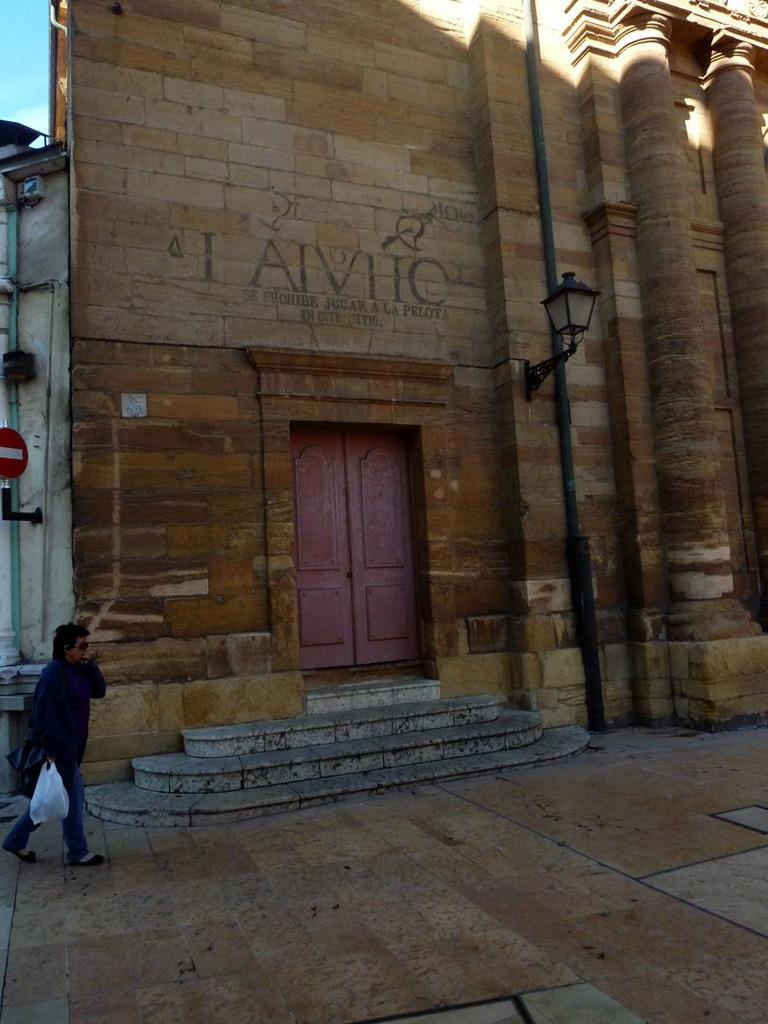What is happening in the image? There is a person in the image, and they are walking. What is the person holding in the image? The person is holding a clover, which is white. What can be seen in the background of the image? There is a building in the background of the image, and it is brown. What is the color of the sky in the image? The sky is blue in the image. Is the person in the image trying to escape from quicksand? There is no quicksand present in the image, so the person is not trying to escape from it. 